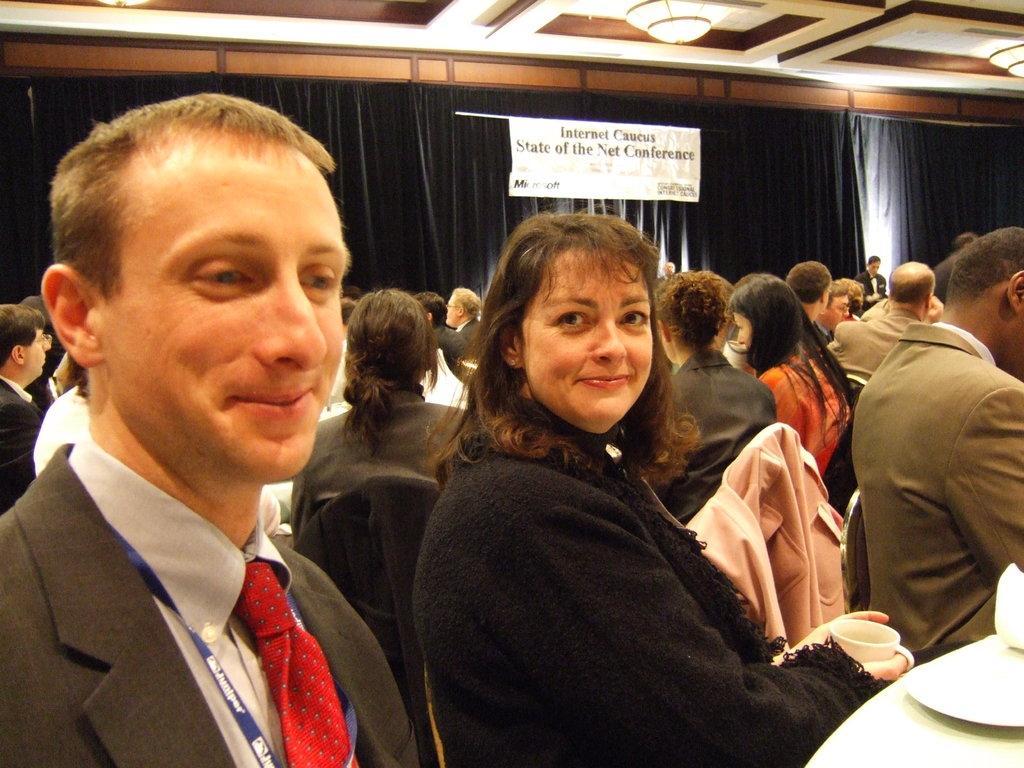In one or two sentences, can you explain what this image depicts? In this picture I can see few people are seated on the chairs and I can see a woman holding a cup in her hand and a plate on the table and I can see a black color cloth with a banner on it and I can see text on the banner and a man standing and I can see few lights on the ceiling. 